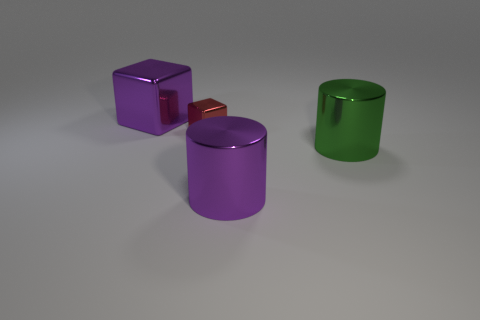Is there a large metal thing that has the same color as the large block?
Give a very brief answer. Yes. Does the purple block have the same size as the green metal cylinder?
Offer a very short reply. Yes. Is the color of the small cube the same as the large shiny block on the left side of the red metal object?
Keep it short and to the point. No. There is a big green object that is the same material as the red thing; what shape is it?
Your answer should be compact. Cylinder. There is a metal thing that is behind the tiny block; does it have the same shape as the green metallic object?
Ensure brevity in your answer.  No. There is a green cylinder right of the purple object behind the tiny cube; what is its size?
Your answer should be compact. Large. There is another cylinder that is made of the same material as the large purple cylinder; what is its color?
Give a very brief answer. Green. How many red metal blocks have the same size as the green object?
Provide a short and direct response. 0. What number of yellow objects are either small metallic things or metallic blocks?
Provide a short and direct response. 0. What number of things are small purple shiny blocks or big purple things that are left of the tiny metallic thing?
Offer a very short reply. 1. 